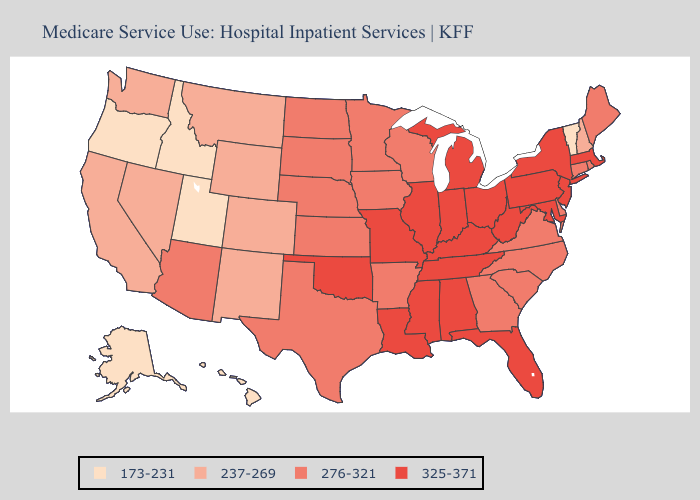Does Maine have the lowest value in the Northeast?
Concise answer only. No. What is the highest value in the Northeast ?
Keep it brief. 325-371. Does the first symbol in the legend represent the smallest category?
Concise answer only. Yes. Does Wisconsin have the same value as Florida?
Write a very short answer. No. Which states have the lowest value in the South?
Be succinct. Arkansas, Delaware, Georgia, North Carolina, South Carolina, Texas, Virginia. Name the states that have a value in the range 173-231?
Quick response, please. Alaska, Hawaii, Idaho, Oregon, Utah, Vermont. What is the highest value in the USA?
Answer briefly. 325-371. Name the states that have a value in the range 237-269?
Be succinct. California, Colorado, Montana, Nevada, New Hampshire, New Mexico, Washington, Wyoming. Among the states that border Delaware , which have the lowest value?
Give a very brief answer. Maryland, New Jersey, Pennsylvania. Name the states that have a value in the range 237-269?
Quick response, please. California, Colorado, Montana, Nevada, New Hampshire, New Mexico, Washington, Wyoming. Does Nebraska have the same value as North Dakota?
Keep it brief. Yes. Name the states that have a value in the range 276-321?
Be succinct. Arizona, Arkansas, Connecticut, Delaware, Georgia, Iowa, Kansas, Maine, Minnesota, Nebraska, North Carolina, North Dakota, Rhode Island, South Carolina, South Dakota, Texas, Virginia, Wisconsin. What is the lowest value in the South?
Be succinct. 276-321. Name the states that have a value in the range 237-269?
Answer briefly. California, Colorado, Montana, Nevada, New Hampshire, New Mexico, Washington, Wyoming. Name the states that have a value in the range 173-231?
Quick response, please. Alaska, Hawaii, Idaho, Oregon, Utah, Vermont. 